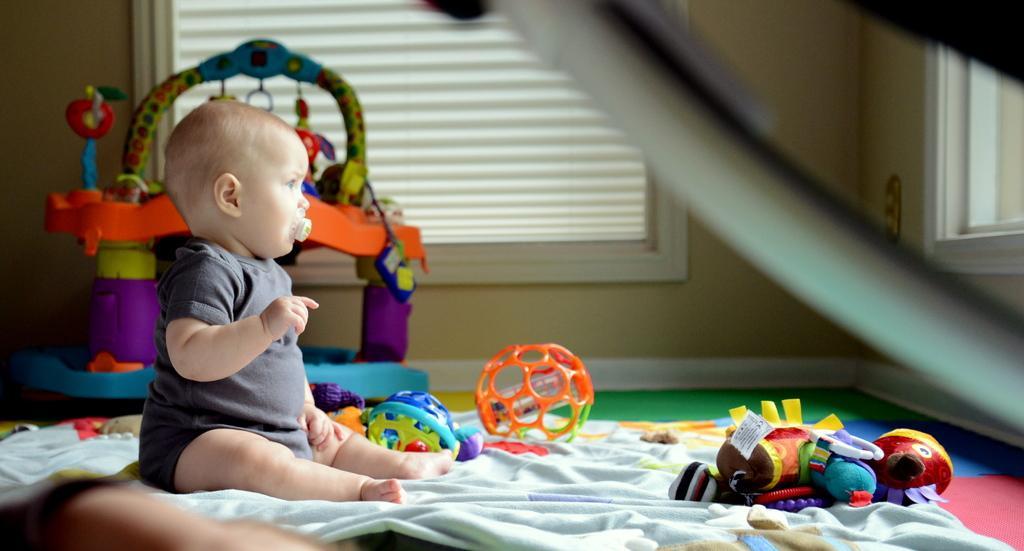Can you describe this image briefly? In this picture there is a kid sitting and there are toys. At the back there is a toy and there are windows. At the bottom there is a floor. 